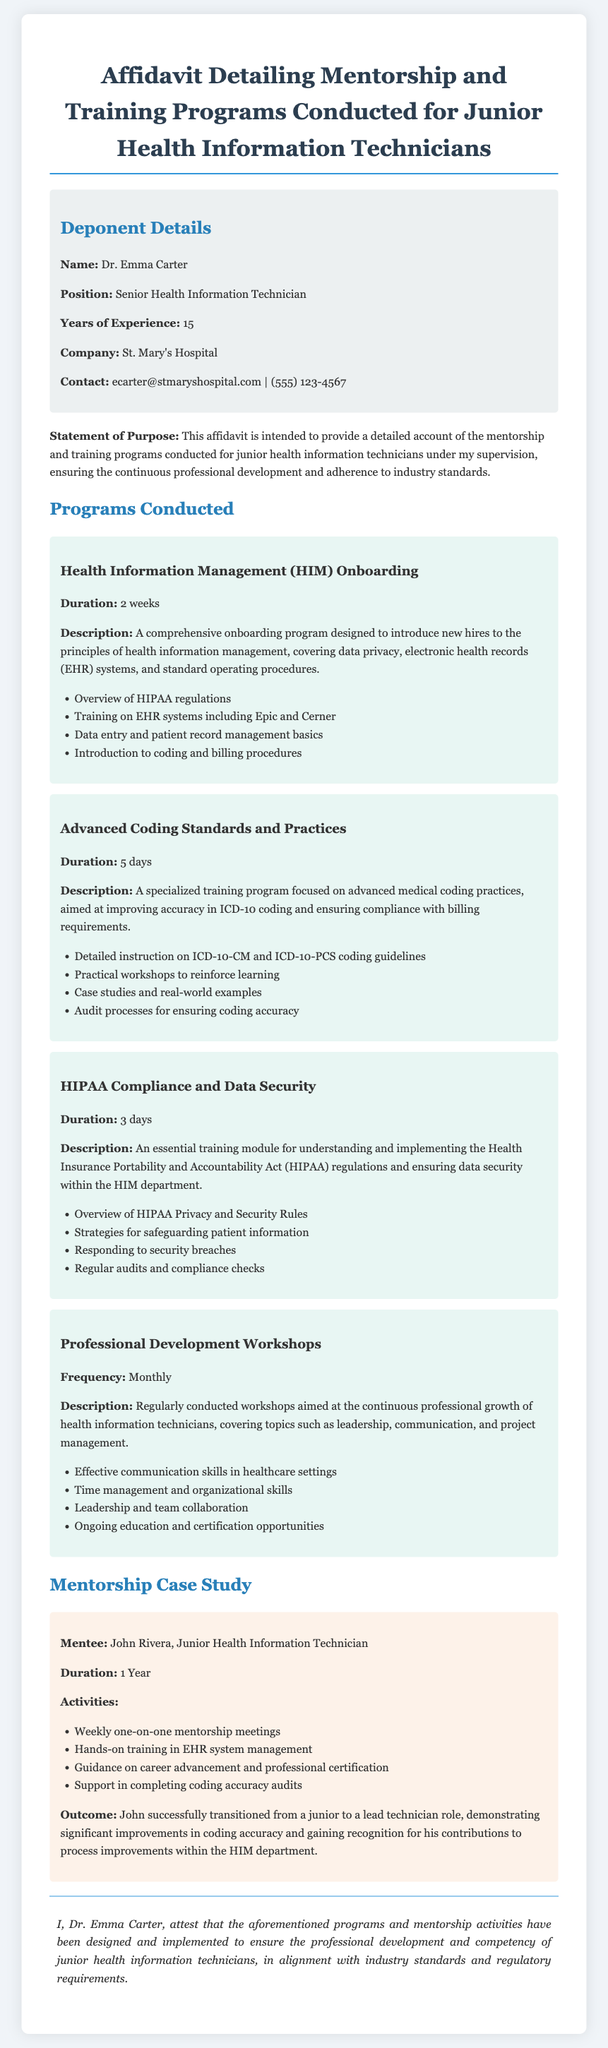What is the name of the deponent? The deponent's name is mentioned at the beginning of the document in the Deponent Details section.
Answer: Dr. Emma Carter What is the position of the deponent? The position of the deponent is provided in the Deponent Details section.
Answer: Senior Health Information Technician How many years of experience does the deponent have? The years of experience for the deponent is stated in the Deponent Details section.
Answer: 15 What is the duration of the Health Information Management onboarding program? The duration of the program is specified in the Programs Conducted section.
Answer: 2 weeks Who was the mentee mentioned in the case study? The mentee's name is included in the Mentorship Case Study section.
Answer: John Rivera What was the outcome for the mentee after the mentorship? The outcome for the mentee is provided in the Mentorship Case Study section.
Answer: Lead technician role What is the frequency of the Professional Development Workshops? The frequency of the workshops is stated in the Programs Conducted section.
Answer: Monthly What is the primary purpose of the affidavit as stated in the document? The purpose of the affidavit is explained in the Statement of Purpose section.
Answer: Continuous professional development How many days is the HIPAA Compliance and Data Security training? The duration of the training is mentioned in the Programs Conducted section.
Answer: 3 days 